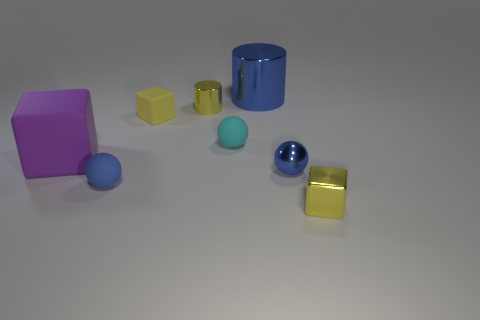What is the material of the big thing that is the same color as the metal ball?
Make the answer very short. Metal. What color is the cube that is the same material as the large blue thing?
Your response must be concise. Yellow. Are there any other things that have the same size as the purple object?
Your answer should be compact. Yes. There is a small matte sphere behind the big cube; is its color the same as the tiny matte sphere left of the small cyan matte thing?
Your response must be concise. No. Are there more blue matte spheres behind the small yellow metal block than tiny metal balls in front of the blue rubber ball?
Ensure brevity in your answer.  Yes. The other tiny rubber thing that is the same shape as the blue rubber thing is what color?
Ensure brevity in your answer.  Cyan. Is there any other thing that has the same shape as the purple matte object?
Your answer should be very brief. Yes. Is the shape of the small cyan object the same as the large object in front of the big blue object?
Give a very brief answer. No. What number of other objects are the same material as the purple cube?
Provide a short and direct response. 3. There is a tiny metal block; is its color the same as the small metal cylinder that is right of the yellow rubber cube?
Your answer should be very brief. Yes. 